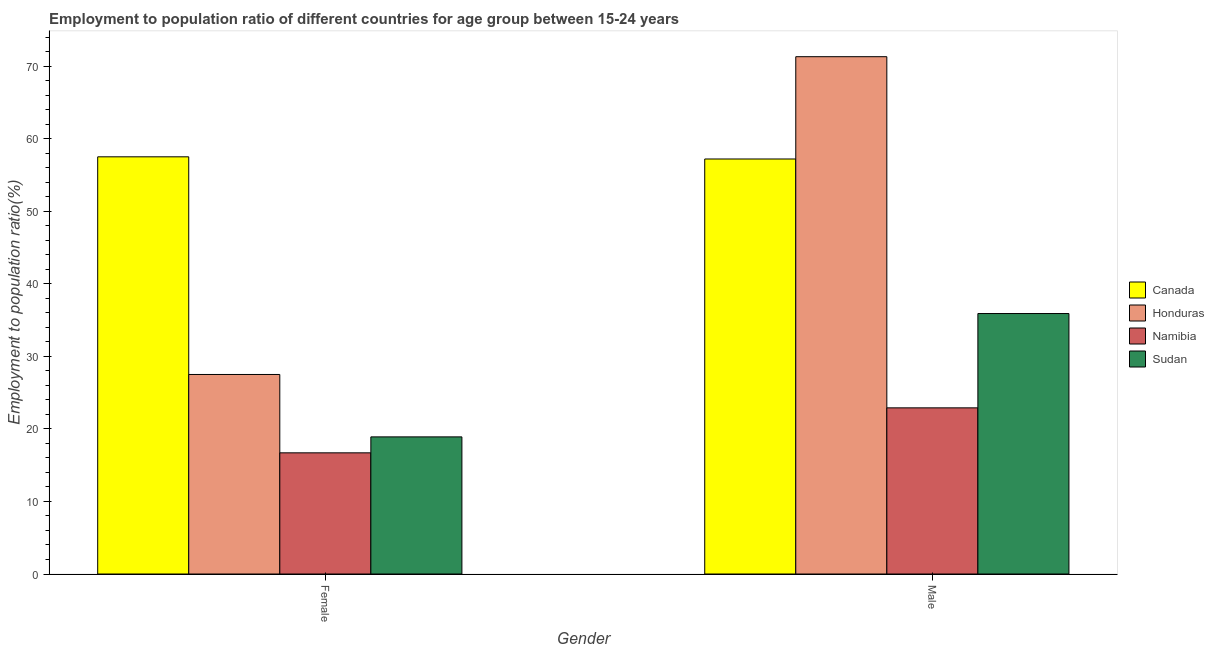Are the number of bars on each tick of the X-axis equal?
Keep it short and to the point. Yes. What is the employment to population ratio(male) in Honduras?
Your answer should be very brief. 71.3. Across all countries, what is the maximum employment to population ratio(male)?
Give a very brief answer. 71.3. Across all countries, what is the minimum employment to population ratio(male)?
Offer a very short reply. 22.9. In which country was the employment to population ratio(female) minimum?
Provide a short and direct response. Namibia. What is the total employment to population ratio(male) in the graph?
Offer a terse response. 187.3. What is the difference between the employment to population ratio(male) in Honduras and that in Canada?
Keep it short and to the point. 14.1. What is the difference between the employment to population ratio(male) in Honduras and the employment to population ratio(female) in Sudan?
Your answer should be very brief. 52.4. What is the average employment to population ratio(female) per country?
Your answer should be very brief. 30.15. What is the difference between the employment to population ratio(male) and employment to population ratio(female) in Honduras?
Provide a succinct answer. 43.8. What is the ratio of the employment to population ratio(male) in Honduras to that in Canada?
Keep it short and to the point. 1.25. Is the employment to population ratio(male) in Sudan less than that in Honduras?
Your answer should be very brief. Yes. In how many countries, is the employment to population ratio(female) greater than the average employment to population ratio(female) taken over all countries?
Offer a terse response. 1. What does the 1st bar from the left in Male represents?
Give a very brief answer. Canada. What does the 3rd bar from the right in Female represents?
Offer a very short reply. Honduras. Are all the bars in the graph horizontal?
Offer a terse response. No. How many countries are there in the graph?
Your answer should be compact. 4. Where does the legend appear in the graph?
Provide a succinct answer. Center right. What is the title of the graph?
Make the answer very short. Employment to population ratio of different countries for age group between 15-24 years. Does "Portugal" appear as one of the legend labels in the graph?
Provide a short and direct response. No. What is the label or title of the X-axis?
Your answer should be compact. Gender. What is the Employment to population ratio(%) in Canada in Female?
Your answer should be compact. 57.5. What is the Employment to population ratio(%) of Namibia in Female?
Your response must be concise. 16.7. What is the Employment to population ratio(%) of Sudan in Female?
Ensure brevity in your answer.  18.9. What is the Employment to population ratio(%) of Canada in Male?
Offer a terse response. 57.2. What is the Employment to population ratio(%) in Honduras in Male?
Keep it short and to the point. 71.3. What is the Employment to population ratio(%) in Namibia in Male?
Ensure brevity in your answer.  22.9. What is the Employment to population ratio(%) in Sudan in Male?
Make the answer very short. 35.9. Across all Gender, what is the maximum Employment to population ratio(%) of Canada?
Make the answer very short. 57.5. Across all Gender, what is the maximum Employment to population ratio(%) in Honduras?
Provide a short and direct response. 71.3. Across all Gender, what is the maximum Employment to population ratio(%) in Namibia?
Keep it short and to the point. 22.9. Across all Gender, what is the maximum Employment to population ratio(%) in Sudan?
Offer a terse response. 35.9. Across all Gender, what is the minimum Employment to population ratio(%) of Canada?
Provide a short and direct response. 57.2. Across all Gender, what is the minimum Employment to population ratio(%) of Namibia?
Give a very brief answer. 16.7. Across all Gender, what is the minimum Employment to population ratio(%) in Sudan?
Your answer should be compact. 18.9. What is the total Employment to population ratio(%) of Canada in the graph?
Offer a very short reply. 114.7. What is the total Employment to population ratio(%) of Honduras in the graph?
Give a very brief answer. 98.8. What is the total Employment to population ratio(%) in Namibia in the graph?
Provide a succinct answer. 39.6. What is the total Employment to population ratio(%) in Sudan in the graph?
Provide a short and direct response. 54.8. What is the difference between the Employment to population ratio(%) of Honduras in Female and that in Male?
Your answer should be compact. -43.8. What is the difference between the Employment to population ratio(%) of Namibia in Female and that in Male?
Your answer should be compact. -6.2. What is the difference between the Employment to population ratio(%) of Sudan in Female and that in Male?
Your answer should be very brief. -17. What is the difference between the Employment to population ratio(%) in Canada in Female and the Employment to population ratio(%) in Namibia in Male?
Offer a terse response. 34.6. What is the difference between the Employment to population ratio(%) of Canada in Female and the Employment to population ratio(%) of Sudan in Male?
Your answer should be compact. 21.6. What is the difference between the Employment to population ratio(%) in Honduras in Female and the Employment to population ratio(%) in Sudan in Male?
Your answer should be compact. -8.4. What is the difference between the Employment to population ratio(%) of Namibia in Female and the Employment to population ratio(%) of Sudan in Male?
Your answer should be compact. -19.2. What is the average Employment to population ratio(%) of Canada per Gender?
Ensure brevity in your answer.  57.35. What is the average Employment to population ratio(%) in Honduras per Gender?
Provide a short and direct response. 49.4. What is the average Employment to population ratio(%) of Namibia per Gender?
Your answer should be compact. 19.8. What is the average Employment to population ratio(%) of Sudan per Gender?
Ensure brevity in your answer.  27.4. What is the difference between the Employment to population ratio(%) of Canada and Employment to population ratio(%) of Namibia in Female?
Your answer should be compact. 40.8. What is the difference between the Employment to population ratio(%) in Canada and Employment to population ratio(%) in Sudan in Female?
Ensure brevity in your answer.  38.6. What is the difference between the Employment to population ratio(%) of Namibia and Employment to population ratio(%) of Sudan in Female?
Your response must be concise. -2.2. What is the difference between the Employment to population ratio(%) in Canada and Employment to population ratio(%) in Honduras in Male?
Give a very brief answer. -14.1. What is the difference between the Employment to population ratio(%) in Canada and Employment to population ratio(%) in Namibia in Male?
Give a very brief answer. 34.3. What is the difference between the Employment to population ratio(%) of Canada and Employment to population ratio(%) of Sudan in Male?
Ensure brevity in your answer.  21.3. What is the difference between the Employment to population ratio(%) of Honduras and Employment to population ratio(%) of Namibia in Male?
Provide a short and direct response. 48.4. What is the difference between the Employment to population ratio(%) in Honduras and Employment to population ratio(%) in Sudan in Male?
Offer a very short reply. 35.4. What is the difference between the Employment to population ratio(%) of Namibia and Employment to population ratio(%) of Sudan in Male?
Make the answer very short. -13. What is the ratio of the Employment to population ratio(%) in Canada in Female to that in Male?
Provide a succinct answer. 1.01. What is the ratio of the Employment to population ratio(%) of Honduras in Female to that in Male?
Keep it short and to the point. 0.39. What is the ratio of the Employment to population ratio(%) of Namibia in Female to that in Male?
Offer a very short reply. 0.73. What is the ratio of the Employment to population ratio(%) in Sudan in Female to that in Male?
Provide a succinct answer. 0.53. What is the difference between the highest and the second highest Employment to population ratio(%) of Honduras?
Offer a terse response. 43.8. What is the difference between the highest and the second highest Employment to population ratio(%) in Namibia?
Ensure brevity in your answer.  6.2. What is the difference between the highest and the lowest Employment to population ratio(%) of Canada?
Your answer should be compact. 0.3. What is the difference between the highest and the lowest Employment to population ratio(%) of Honduras?
Your answer should be compact. 43.8. What is the difference between the highest and the lowest Employment to population ratio(%) of Namibia?
Your answer should be compact. 6.2. 